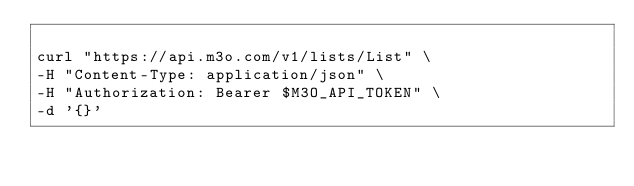Convert code to text. <code><loc_0><loc_0><loc_500><loc_500><_Bash_>
curl "https://api.m3o.com/v1/lists/List" \
-H "Content-Type: application/json" \
-H "Authorization: Bearer $M3O_API_TOKEN" \
-d '{}'
</code> 